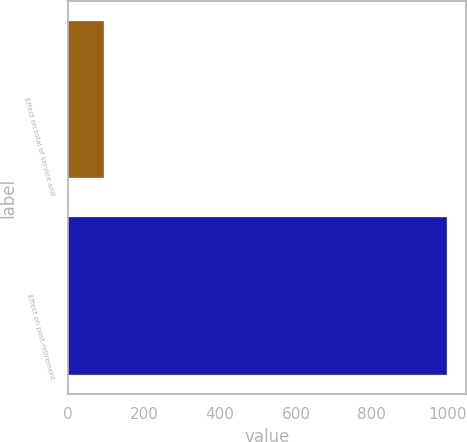Convert chart. <chart><loc_0><loc_0><loc_500><loc_500><bar_chart><fcel>Effect on total of service and<fcel>Effect on post-retirement<nl><fcel>94<fcel>999<nl></chart> 